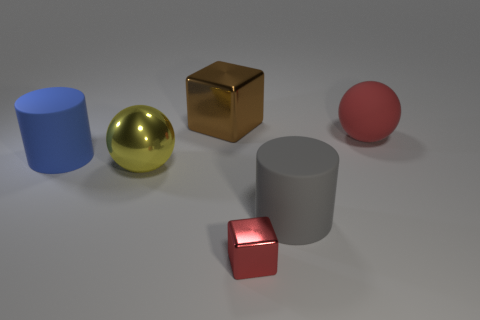The rubber thing that is behind the cylinder that is to the left of the metallic cube to the left of the tiny metal object is what color?
Offer a terse response. Red. Do the big yellow thing and the cylinder that is to the right of the tiny cube have the same material?
Offer a very short reply. No. The other object that is the same shape as the tiny metallic object is what size?
Give a very brief answer. Large. Are there the same number of red rubber objects that are left of the big yellow object and metal things that are behind the tiny red thing?
Make the answer very short. No. What number of other objects are the same material as the gray thing?
Your answer should be compact. 2. Is the number of small red shiny objects that are in front of the small red cube the same as the number of large blue shiny cylinders?
Provide a succinct answer. Yes. There is a blue rubber cylinder; is its size the same as the sphere that is on the left side of the gray cylinder?
Your answer should be compact. Yes. There is a big metal thing behind the big blue cylinder; what shape is it?
Provide a succinct answer. Cube. Is there a large yellow metal sphere?
Your answer should be compact. Yes. There is a cylinder left of the tiny red metal block; is its size the same as the ball on the left side of the large metallic cube?
Your answer should be very brief. Yes. 